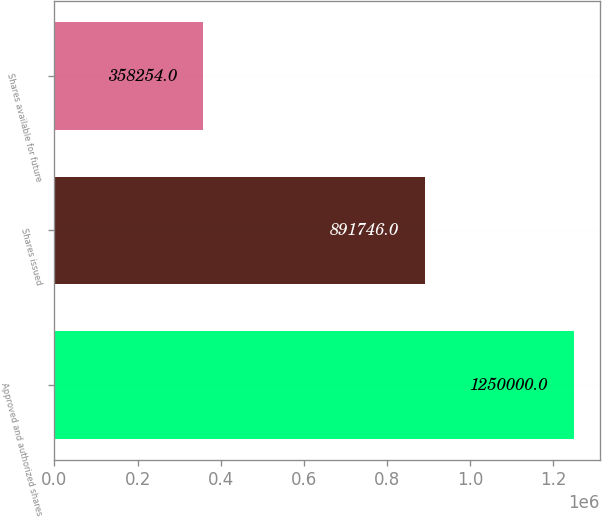<chart> <loc_0><loc_0><loc_500><loc_500><bar_chart><fcel>Approved and authorized shares<fcel>Shares issued<fcel>Shares available for future<nl><fcel>1.25e+06<fcel>891746<fcel>358254<nl></chart> 